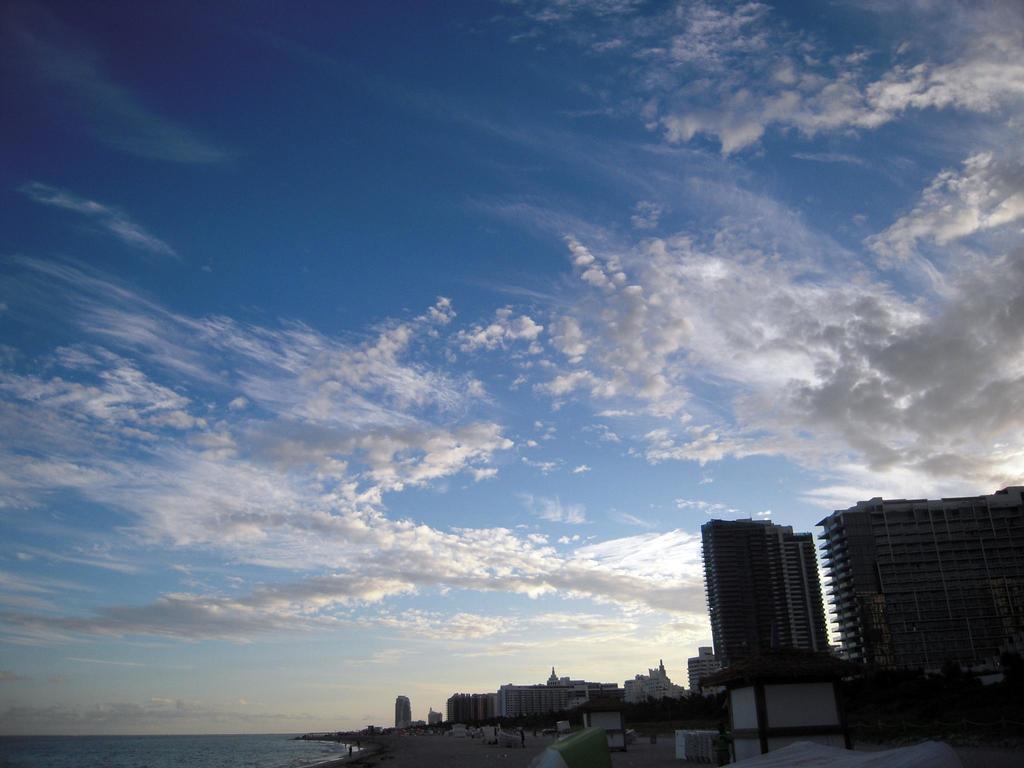Please provide a concise description of this image. In this picture we can see buildings, people, trees, water and some objects and in the background we can see sky with clouds. 